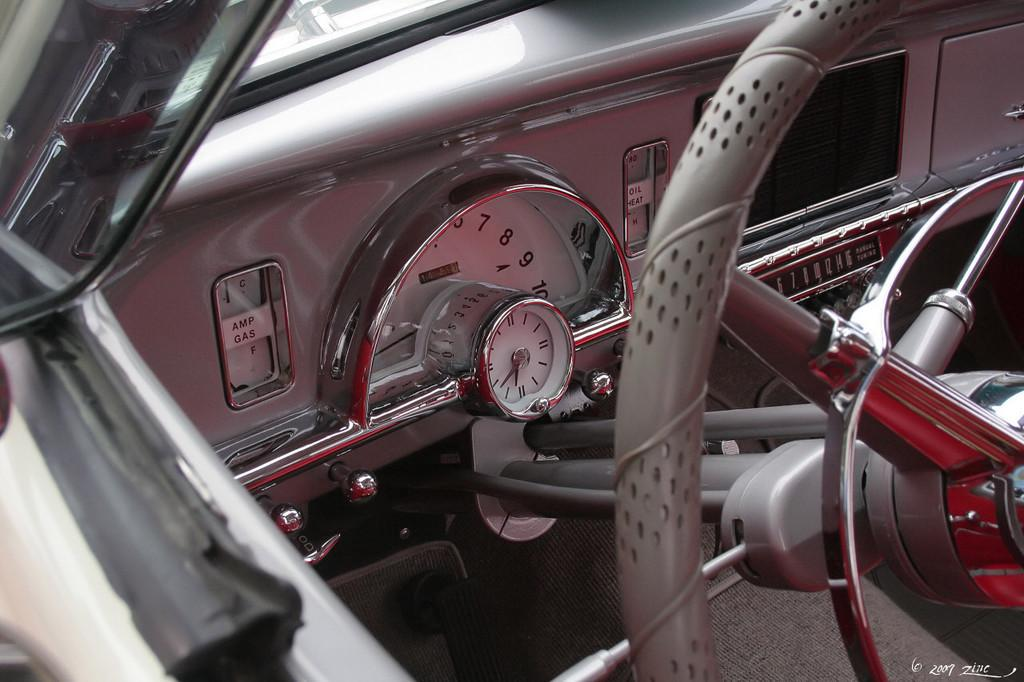What type of location is depicted in the image? The image shows an inside view of a vehicle. What is the primary control mechanism in the vehicle? There is a steering wheel in the image. What can be used to monitor the vehicle's performance? Gauges are present in the image. What else can be seen inside the vehicle? There are objects visible in the image. Where is the side mirror located in the vehicle? There is a side mirror on the left side of the vehicle. Can you see any magic spells being cast in the image? There is no mention of magic or spells in the image; it shows the inside of a vehicle with a steering wheel, gauges, objects, and a side mirror. 